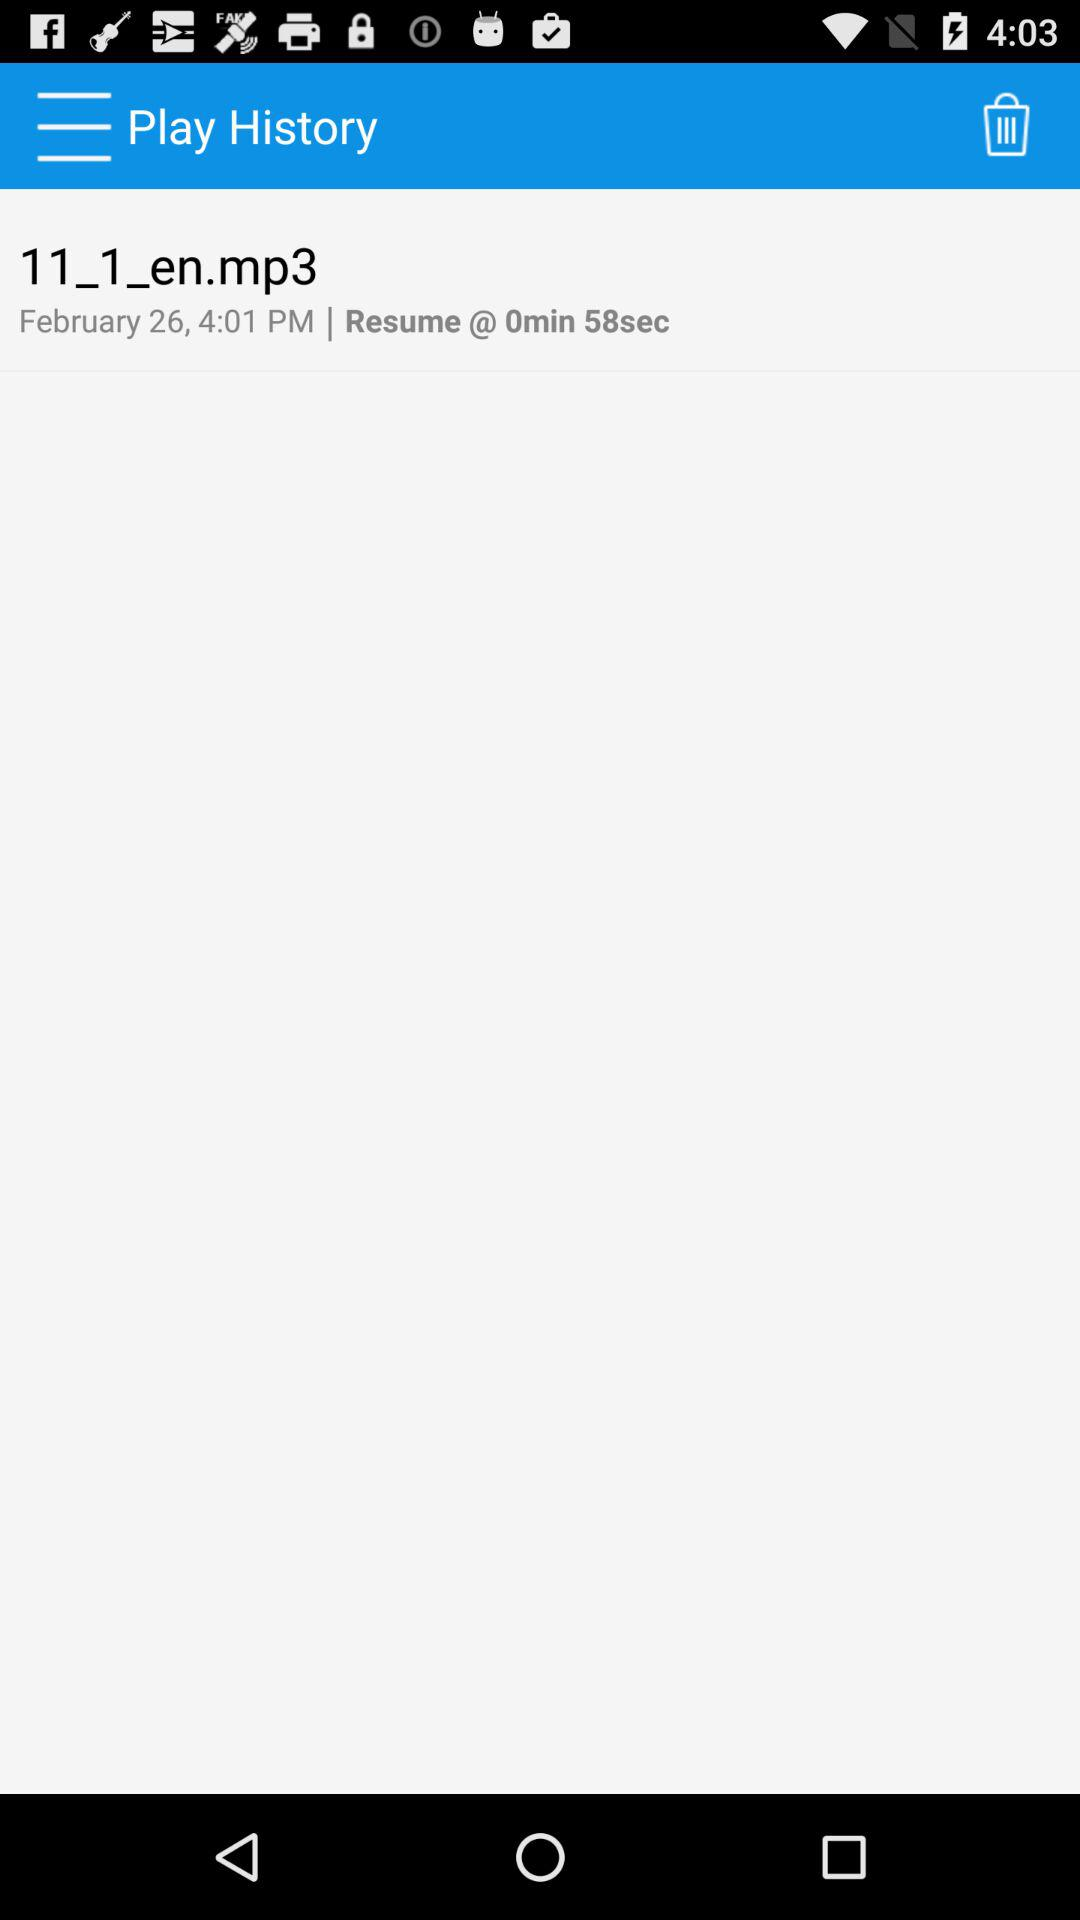What is the given date? The given date is February 26. 